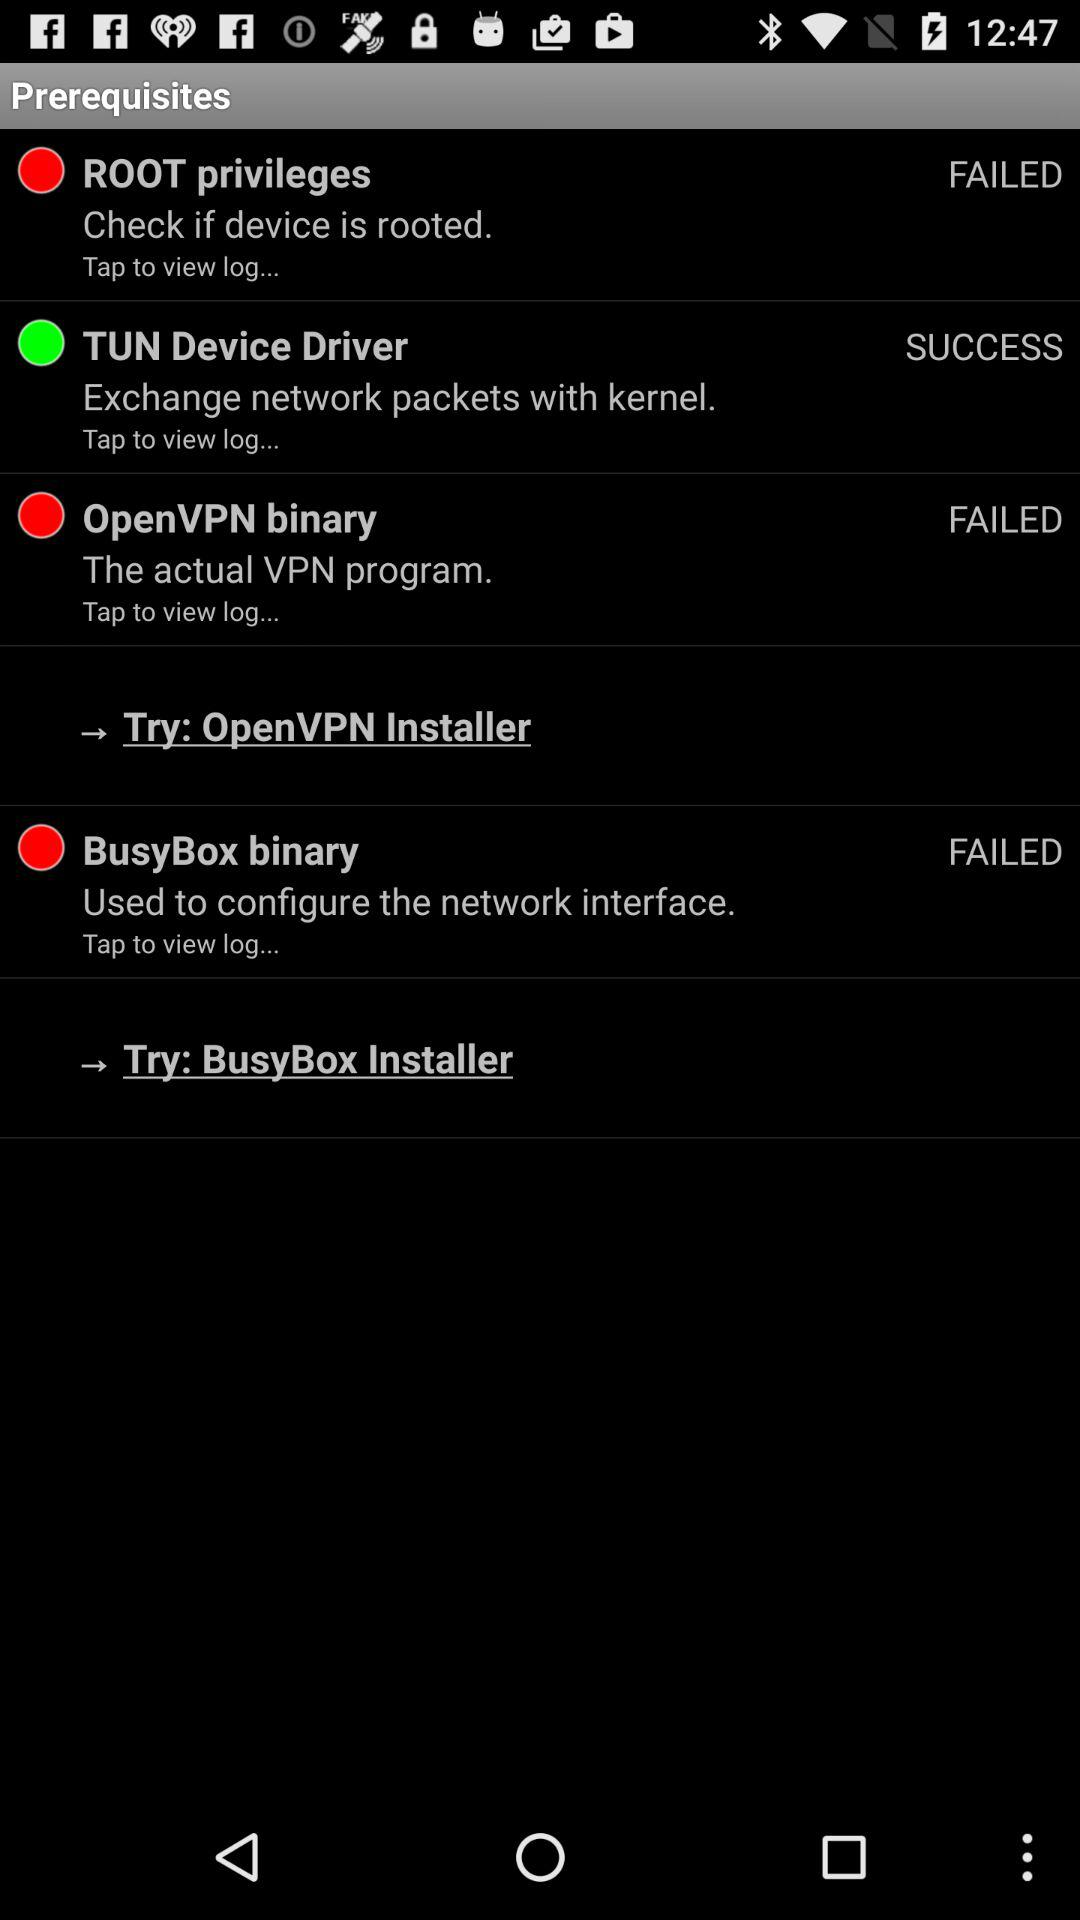How many prerequisites are there with a green circle?
Answer the question using a single word or phrase. 1 